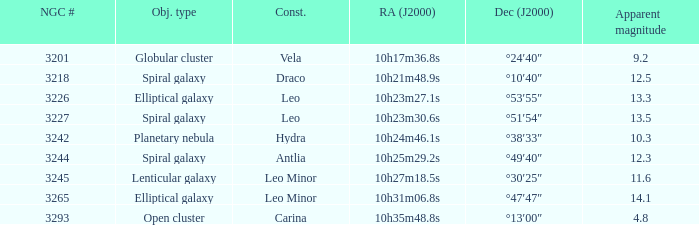What is the Apparent magnitude of a globular cluster? 9.2. 